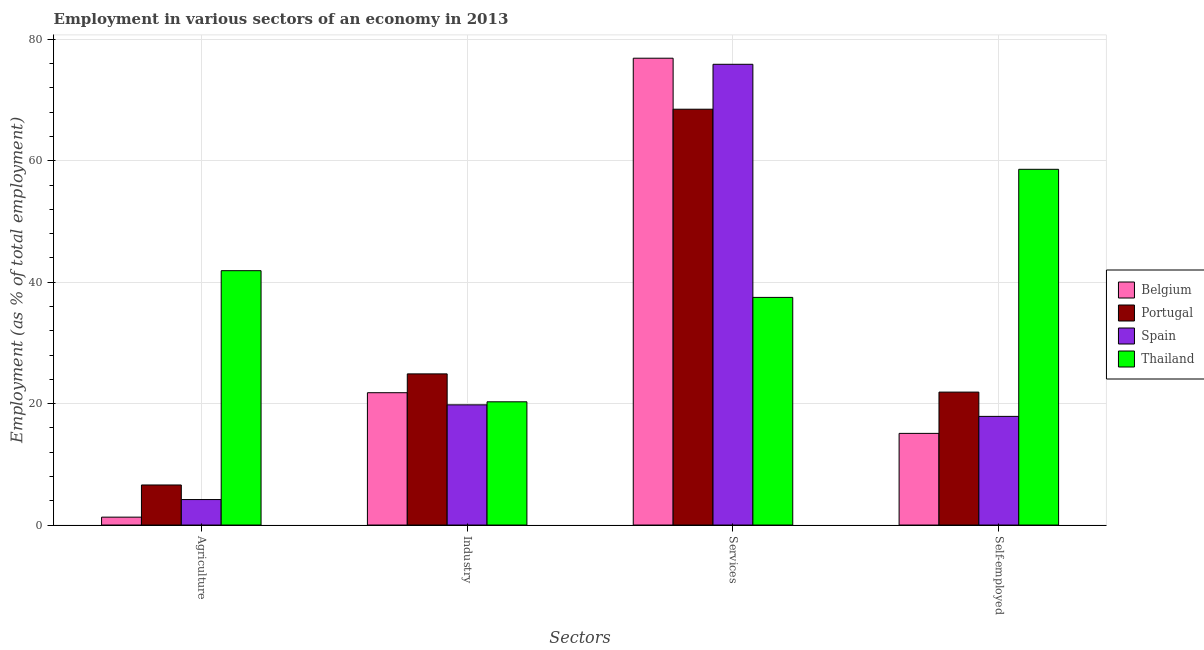How many different coloured bars are there?
Make the answer very short. 4. What is the label of the 1st group of bars from the left?
Offer a terse response. Agriculture. What is the percentage of self employed workers in Portugal?
Your response must be concise. 21.9. Across all countries, what is the maximum percentage of self employed workers?
Offer a very short reply. 58.6. Across all countries, what is the minimum percentage of workers in services?
Offer a terse response. 37.5. In which country was the percentage of workers in services maximum?
Give a very brief answer. Belgium. What is the total percentage of self employed workers in the graph?
Offer a terse response. 113.5. What is the difference between the percentage of self employed workers in Spain and that in Thailand?
Offer a very short reply. -40.7. What is the difference between the percentage of workers in agriculture in Spain and the percentage of workers in industry in Belgium?
Give a very brief answer. -17.6. What is the average percentage of workers in industry per country?
Provide a succinct answer. 21.7. What is the difference between the percentage of workers in agriculture and percentage of workers in services in Spain?
Your answer should be compact. -71.7. What is the ratio of the percentage of self employed workers in Portugal to that in Belgium?
Keep it short and to the point. 1.45. What is the difference between the highest and the second highest percentage of workers in agriculture?
Your answer should be very brief. 35.3. What is the difference between the highest and the lowest percentage of workers in services?
Give a very brief answer. 39.4. In how many countries, is the percentage of self employed workers greater than the average percentage of self employed workers taken over all countries?
Your answer should be very brief. 1. What does the 3rd bar from the left in Self-employed represents?
Ensure brevity in your answer.  Spain. Is it the case that in every country, the sum of the percentage of workers in agriculture and percentage of workers in industry is greater than the percentage of workers in services?
Make the answer very short. No. How many countries are there in the graph?
Offer a very short reply. 4. What is the difference between two consecutive major ticks on the Y-axis?
Your answer should be very brief. 20. Does the graph contain grids?
Ensure brevity in your answer.  Yes. How many legend labels are there?
Make the answer very short. 4. How are the legend labels stacked?
Offer a terse response. Vertical. What is the title of the graph?
Keep it short and to the point. Employment in various sectors of an economy in 2013. What is the label or title of the X-axis?
Your response must be concise. Sectors. What is the label or title of the Y-axis?
Give a very brief answer. Employment (as % of total employment). What is the Employment (as % of total employment) of Belgium in Agriculture?
Offer a very short reply. 1.3. What is the Employment (as % of total employment) in Portugal in Agriculture?
Your answer should be compact. 6.6. What is the Employment (as % of total employment) of Spain in Agriculture?
Make the answer very short. 4.2. What is the Employment (as % of total employment) of Thailand in Agriculture?
Ensure brevity in your answer.  41.9. What is the Employment (as % of total employment) of Belgium in Industry?
Your answer should be very brief. 21.8. What is the Employment (as % of total employment) in Portugal in Industry?
Provide a short and direct response. 24.9. What is the Employment (as % of total employment) in Spain in Industry?
Your answer should be compact. 19.8. What is the Employment (as % of total employment) of Thailand in Industry?
Make the answer very short. 20.3. What is the Employment (as % of total employment) of Belgium in Services?
Your answer should be very brief. 76.9. What is the Employment (as % of total employment) in Portugal in Services?
Provide a succinct answer. 68.5. What is the Employment (as % of total employment) in Spain in Services?
Your response must be concise. 75.9. What is the Employment (as % of total employment) of Thailand in Services?
Ensure brevity in your answer.  37.5. What is the Employment (as % of total employment) of Belgium in Self-employed?
Provide a succinct answer. 15.1. What is the Employment (as % of total employment) of Portugal in Self-employed?
Offer a terse response. 21.9. What is the Employment (as % of total employment) in Spain in Self-employed?
Make the answer very short. 17.9. What is the Employment (as % of total employment) of Thailand in Self-employed?
Your response must be concise. 58.6. Across all Sectors, what is the maximum Employment (as % of total employment) of Belgium?
Make the answer very short. 76.9. Across all Sectors, what is the maximum Employment (as % of total employment) of Portugal?
Give a very brief answer. 68.5. Across all Sectors, what is the maximum Employment (as % of total employment) of Spain?
Offer a very short reply. 75.9. Across all Sectors, what is the maximum Employment (as % of total employment) in Thailand?
Ensure brevity in your answer.  58.6. Across all Sectors, what is the minimum Employment (as % of total employment) in Belgium?
Ensure brevity in your answer.  1.3. Across all Sectors, what is the minimum Employment (as % of total employment) in Portugal?
Offer a very short reply. 6.6. Across all Sectors, what is the minimum Employment (as % of total employment) of Spain?
Make the answer very short. 4.2. Across all Sectors, what is the minimum Employment (as % of total employment) in Thailand?
Provide a succinct answer. 20.3. What is the total Employment (as % of total employment) in Belgium in the graph?
Your answer should be compact. 115.1. What is the total Employment (as % of total employment) of Portugal in the graph?
Offer a very short reply. 121.9. What is the total Employment (as % of total employment) in Spain in the graph?
Give a very brief answer. 117.8. What is the total Employment (as % of total employment) in Thailand in the graph?
Offer a very short reply. 158.3. What is the difference between the Employment (as % of total employment) of Belgium in Agriculture and that in Industry?
Your answer should be compact. -20.5. What is the difference between the Employment (as % of total employment) of Portugal in Agriculture and that in Industry?
Your response must be concise. -18.3. What is the difference between the Employment (as % of total employment) of Spain in Agriculture and that in Industry?
Provide a short and direct response. -15.6. What is the difference between the Employment (as % of total employment) in Thailand in Agriculture and that in Industry?
Give a very brief answer. 21.6. What is the difference between the Employment (as % of total employment) in Belgium in Agriculture and that in Services?
Provide a short and direct response. -75.6. What is the difference between the Employment (as % of total employment) in Portugal in Agriculture and that in Services?
Provide a short and direct response. -61.9. What is the difference between the Employment (as % of total employment) of Spain in Agriculture and that in Services?
Your answer should be compact. -71.7. What is the difference between the Employment (as % of total employment) in Portugal in Agriculture and that in Self-employed?
Give a very brief answer. -15.3. What is the difference between the Employment (as % of total employment) in Spain in Agriculture and that in Self-employed?
Your answer should be compact. -13.7. What is the difference between the Employment (as % of total employment) in Thailand in Agriculture and that in Self-employed?
Give a very brief answer. -16.7. What is the difference between the Employment (as % of total employment) of Belgium in Industry and that in Services?
Your answer should be compact. -55.1. What is the difference between the Employment (as % of total employment) in Portugal in Industry and that in Services?
Provide a short and direct response. -43.6. What is the difference between the Employment (as % of total employment) in Spain in Industry and that in Services?
Your response must be concise. -56.1. What is the difference between the Employment (as % of total employment) of Thailand in Industry and that in Services?
Your answer should be compact. -17.2. What is the difference between the Employment (as % of total employment) in Spain in Industry and that in Self-employed?
Make the answer very short. 1.9. What is the difference between the Employment (as % of total employment) of Thailand in Industry and that in Self-employed?
Your response must be concise. -38.3. What is the difference between the Employment (as % of total employment) of Belgium in Services and that in Self-employed?
Provide a short and direct response. 61.8. What is the difference between the Employment (as % of total employment) of Portugal in Services and that in Self-employed?
Your response must be concise. 46.6. What is the difference between the Employment (as % of total employment) of Thailand in Services and that in Self-employed?
Provide a short and direct response. -21.1. What is the difference between the Employment (as % of total employment) in Belgium in Agriculture and the Employment (as % of total employment) in Portugal in Industry?
Provide a succinct answer. -23.6. What is the difference between the Employment (as % of total employment) of Belgium in Agriculture and the Employment (as % of total employment) of Spain in Industry?
Provide a short and direct response. -18.5. What is the difference between the Employment (as % of total employment) of Portugal in Agriculture and the Employment (as % of total employment) of Spain in Industry?
Give a very brief answer. -13.2. What is the difference between the Employment (as % of total employment) in Portugal in Agriculture and the Employment (as % of total employment) in Thailand in Industry?
Offer a terse response. -13.7. What is the difference between the Employment (as % of total employment) of Spain in Agriculture and the Employment (as % of total employment) of Thailand in Industry?
Your response must be concise. -16.1. What is the difference between the Employment (as % of total employment) of Belgium in Agriculture and the Employment (as % of total employment) of Portugal in Services?
Ensure brevity in your answer.  -67.2. What is the difference between the Employment (as % of total employment) of Belgium in Agriculture and the Employment (as % of total employment) of Spain in Services?
Offer a terse response. -74.6. What is the difference between the Employment (as % of total employment) in Belgium in Agriculture and the Employment (as % of total employment) in Thailand in Services?
Provide a succinct answer. -36.2. What is the difference between the Employment (as % of total employment) in Portugal in Agriculture and the Employment (as % of total employment) in Spain in Services?
Provide a short and direct response. -69.3. What is the difference between the Employment (as % of total employment) of Portugal in Agriculture and the Employment (as % of total employment) of Thailand in Services?
Your answer should be very brief. -30.9. What is the difference between the Employment (as % of total employment) in Spain in Agriculture and the Employment (as % of total employment) in Thailand in Services?
Provide a succinct answer. -33.3. What is the difference between the Employment (as % of total employment) of Belgium in Agriculture and the Employment (as % of total employment) of Portugal in Self-employed?
Offer a terse response. -20.6. What is the difference between the Employment (as % of total employment) of Belgium in Agriculture and the Employment (as % of total employment) of Spain in Self-employed?
Give a very brief answer. -16.6. What is the difference between the Employment (as % of total employment) in Belgium in Agriculture and the Employment (as % of total employment) in Thailand in Self-employed?
Offer a terse response. -57.3. What is the difference between the Employment (as % of total employment) in Portugal in Agriculture and the Employment (as % of total employment) in Thailand in Self-employed?
Your answer should be compact. -52. What is the difference between the Employment (as % of total employment) of Spain in Agriculture and the Employment (as % of total employment) of Thailand in Self-employed?
Offer a terse response. -54.4. What is the difference between the Employment (as % of total employment) in Belgium in Industry and the Employment (as % of total employment) in Portugal in Services?
Your answer should be very brief. -46.7. What is the difference between the Employment (as % of total employment) of Belgium in Industry and the Employment (as % of total employment) of Spain in Services?
Ensure brevity in your answer.  -54.1. What is the difference between the Employment (as % of total employment) of Belgium in Industry and the Employment (as % of total employment) of Thailand in Services?
Your response must be concise. -15.7. What is the difference between the Employment (as % of total employment) in Portugal in Industry and the Employment (as % of total employment) in Spain in Services?
Your response must be concise. -51. What is the difference between the Employment (as % of total employment) in Portugal in Industry and the Employment (as % of total employment) in Thailand in Services?
Give a very brief answer. -12.6. What is the difference between the Employment (as % of total employment) in Spain in Industry and the Employment (as % of total employment) in Thailand in Services?
Make the answer very short. -17.7. What is the difference between the Employment (as % of total employment) of Belgium in Industry and the Employment (as % of total employment) of Portugal in Self-employed?
Offer a terse response. -0.1. What is the difference between the Employment (as % of total employment) in Belgium in Industry and the Employment (as % of total employment) in Spain in Self-employed?
Offer a terse response. 3.9. What is the difference between the Employment (as % of total employment) in Belgium in Industry and the Employment (as % of total employment) in Thailand in Self-employed?
Ensure brevity in your answer.  -36.8. What is the difference between the Employment (as % of total employment) in Portugal in Industry and the Employment (as % of total employment) in Thailand in Self-employed?
Your answer should be very brief. -33.7. What is the difference between the Employment (as % of total employment) in Spain in Industry and the Employment (as % of total employment) in Thailand in Self-employed?
Keep it short and to the point. -38.8. What is the difference between the Employment (as % of total employment) in Belgium in Services and the Employment (as % of total employment) in Portugal in Self-employed?
Provide a succinct answer. 55. What is the difference between the Employment (as % of total employment) in Belgium in Services and the Employment (as % of total employment) in Spain in Self-employed?
Make the answer very short. 59. What is the difference between the Employment (as % of total employment) in Belgium in Services and the Employment (as % of total employment) in Thailand in Self-employed?
Your answer should be very brief. 18.3. What is the difference between the Employment (as % of total employment) in Portugal in Services and the Employment (as % of total employment) in Spain in Self-employed?
Offer a very short reply. 50.6. What is the difference between the Employment (as % of total employment) in Portugal in Services and the Employment (as % of total employment) in Thailand in Self-employed?
Your response must be concise. 9.9. What is the average Employment (as % of total employment) of Belgium per Sectors?
Keep it short and to the point. 28.77. What is the average Employment (as % of total employment) in Portugal per Sectors?
Offer a terse response. 30.48. What is the average Employment (as % of total employment) of Spain per Sectors?
Provide a succinct answer. 29.45. What is the average Employment (as % of total employment) of Thailand per Sectors?
Provide a succinct answer. 39.58. What is the difference between the Employment (as % of total employment) in Belgium and Employment (as % of total employment) in Portugal in Agriculture?
Provide a short and direct response. -5.3. What is the difference between the Employment (as % of total employment) of Belgium and Employment (as % of total employment) of Thailand in Agriculture?
Provide a short and direct response. -40.6. What is the difference between the Employment (as % of total employment) of Portugal and Employment (as % of total employment) of Thailand in Agriculture?
Offer a terse response. -35.3. What is the difference between the Employment (as % of total employment) in Spain and Employment (as % of total employment) in Thailand in Agriculture?
Keep it short and to the point. -37.7. What is the difference between the Employment (as % of total employment) of Belgium and Employment (as % of total employment) of Portugal in Industry?
Provide a short and direct response. -3.1. What is the difference between the Employment (as % of total employment) in Belgium and Employment (as % of total employment) in Spain in Industry?
Keep it short and to the point. 2. What is the difference between the Employment (as % of total employment) in Spain and Employment (as % of total employment) in Thailand in Industry?
Provide a short and direct response. -0.5. What is the difference between the Employment (as % of total employment) in Belgium and Employment (as % of total employment) in Portugal in Services?
Provide a succinct answer. 8.4. What is the difference between the Employment (as % of total employment) in Belgium and Employment (as % of total employment) in Thailand in Services?
Ensure brevity in your answer.  39.4. What is the difference between the Employment (as % of total employment) of Spain and Employment (as % of total employment) of Thailand in Services?
Your answer should be very brief. 38.4. What is the difference between the Employment (as % of total employment) in Belgium and Employment (as % of total employment) in Portugal in Self-employed?
Offer a terse response. -6.8. What is the difference between the Employment (as % of total employment) of Belgium and Employment (as % of total employment) of Thailand in Self-employed?
Give a very brief answer. -43.5. What is the difference between the Employment (as % of total employment) in Portugal and Employment (as % of total employment) in Thailand in Self-employed?
Your answer should be very brief. -36.7. What is the difference between the Employment (as % of total employment) in Spain and Employment (as % of total employment) in Thailand in Self-employed?
Your answer should be very brief. -40.7. What is the ratio of the Employment (as % of total employment) of Belgium in Agriculture to that in Industry?
Your answer should be compact. 0.06. What is the ratio of the Employment (as % of total employment) in Portugal in Agriculture to that in Industry?
Your answer should be compact. 0.27. What is the ratio of the Employment (as % of total employment) in Spain in Agriculture to that in Industry?
Provide a succinct answer. 0.21. What is the ratio of the Employment (as % of total employment) in Thailand in Agriculture to that in Industry?
Your response must be concise. 2.06. What is the ratio of the Employment (as % of total employment) of Belgium in Agriculture to that in Services?
Provide a short and direct response. 0.02. What is the ratio of the Employment (as % of total employment) of Portugal in Agriculture to that in Services?
Offer a very short reply. 0.1. What is the ratio of the Employment (as % of total employment) in Spain in Agriculture to that in Services?
Provide a short and direct response. 0.06. What is the ratio of the Employment (as % of total employment) of Thailand in Agriculture to that in Services?
Provide a short and direct response. 1.12. What is the ratio of the Employment (as % of total employment) of Belgium in Agriculture to that in Self-employed?
Give a very brief answer. 0.09. What is the ratio of the Employment (as % of total employment) of Portugal in Agriculture to that in Self-employed?
Make the answer very short. 0.3. What is the ratio of the Employment (as % of total employment) of Spain in Agriculture to that in Self-employed?
Your response must be concise. 0.23. What is the ratio of the Employment (as % of total employment) of Thailand in Agriculture to that in Self-employed?
Offer a terse response. 0.71. What is the ratio of the Employment (as % of total employment) of Belgium in Industry to that in Services?
Ensure brevity in your answer.  0.28. What is the ratio of the Employment (as % of total employment) in Portugal in Industry to that in Services?
Offer a very short reply. 0.36. What is the ratio of the Employment (as % of total employment) in Spain in Industry to that in Services?
Ensure brevity in your answer.  0.26. What is the ratio of the Employment (as % of total employment) of Thailand in Industry to that in Services?
Offer a terse response. 0.54. What is the ratio of the Employment (as % of total employment) of Belgium in Industry to that in Self-employed?
Offer a terse response. 1.44. What is the ratio of the Employment (as % of total employment) in Portugal in Industry to that in Self-employed?
Your response must be concise. 1.14. What is the ratio of the Employment (as % of total employment) in Spain in Industry to that in Self-employed?
Your answer should be compact. 1.11. What is the ratio of the Employment (as % of total employment) of Thailand in Industry to that in Self-employed?
Provide a short and direct response. 0.35. What is the ratio of the Employment (as % of total employment) in Belgium in Services to that in Self-employed?
Offer a terse response. 5.09. What is the ratio of the Employment (as % of total employment) in Portugal in Services to that in Self-employed?
Your response must be concise. 3.13. What is the ratio of the Employment (as % of total employment) of Spain in Services to that in Self-employed?
Offer a very short reply. 4.24. What is the ratio of the Employment (as % of total employment) in Thailand in Services to that in Self-employed?
Provide a short and direct response. 0.64. What is the difference between the highest and the second highest Employment (as % of total employment) in Belgium?
Offer a very short reply. 55.1. What is the difference between the highest and the second highest Employment (as % of total employment) in Portugal?
Your answer should be compact. 43.6. What is the difference between the highest and the second highest Employment (as % of total employment) of Spain?
Provide a short and direct response. 56.1. What is the difference between the highest and the second highest Employment (as % of total employment) of Thailand?
Make the answer very short. 16.7. What is the difference between the highest and the lowest Employment (as % of total employment) of Belgium?
Your answer should be very brief. 75.6. What is the difference between the highest and the lowest Employment (as % of total employment) of Portugal?
Your answer should be compact. 61.9. What is the difference between the highest and the lowest Employment (as % of total employment) of Spain?
Provide a short and direct response. 71.7. What is the difference between the highest and the lowest Employment (as % of total employment) of Thailand?
Your answer should be very brief. 38.3. 